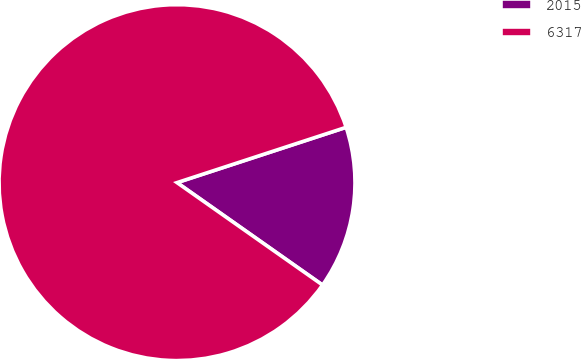<chart> <loc_0><loc_0><loc_500><loc_500><pie_chart><fcel>2015<fcel>6317<nl><fcel>14.79%<fcel>85.21%<nl></chart> 